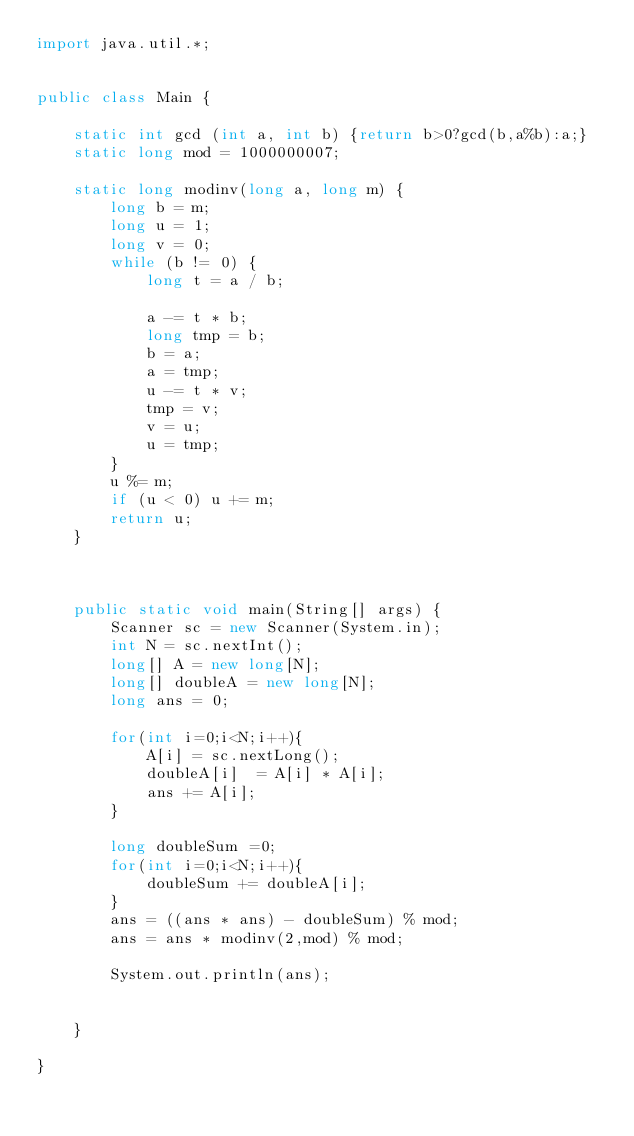<code> <loc_0><loc_0><loc_500><loc_500><_Java_>import java.util.*;


public class Main {

    static int gcd (int a, int b) {return b>0?gcd(b,a%b):a;}
    static long mod = 1000000007;

    static long modinv(long a, long m) {
        long b = m;
        long u = 1;
        long v = 0;
        while (b != 0) {
            long t = a / b;

            a -= t * b;
            long tmp = b;
            b = a;
            a = tmp;
            u -= t * v;
            tmp = v;
            v = u;
            u = tmp;
        }
        u %= m;
        if (u < 0) u += m;
        return u;
    }



    public static void main(String[] args) {
        Scanner sc = new Scanner(System.in);
        int N = sc.nextInt();
        long[] A = new long[N];
        long[] doubleA = new long[N];
        long ans = 0;

        for(int i=0;i<N;i++){
            A[i] = sc.nextLong();
            doubleA[i]  = A[i] * A[i];
            ans += A[i];
        }

        long doubleSum =0;
        for(int i=0;i<N;i++){
            doubleSum += doubleA[i];
        }
        ans = ((ans * ans) - doubleSum) % mod;
        ans = ans * modinv(2,mod) % mod;

        System.out.println(ans);


    }

}


</code> 